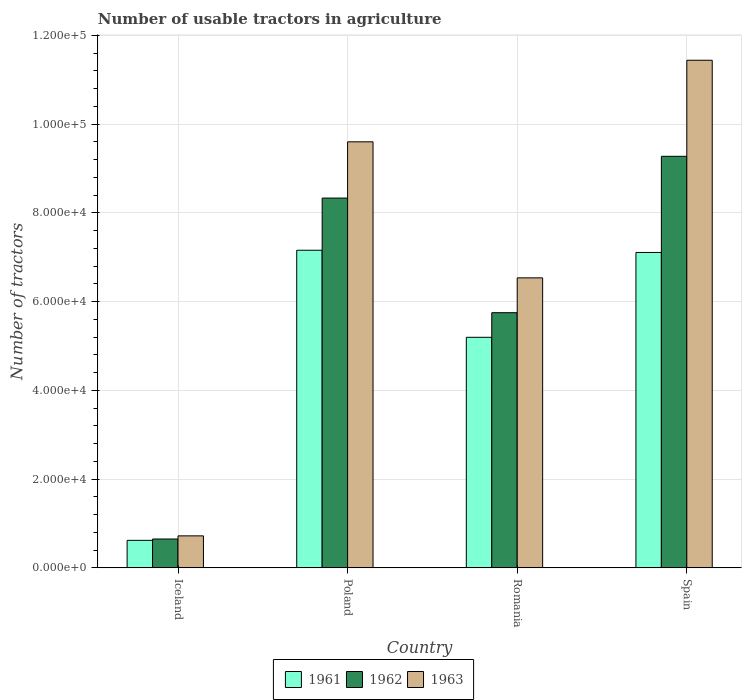Are the number of bars per tick equal to the number of legend labels?
Offer a very short reply. Yes. Are the number of bars on each tick of the X-axis equal?
Your answer should be very brief. Yes. How many bars are there on the 4th tick from the right?
Offer a terse response. 3. What is the number of usable tractors in agriculture in 1961 in Spain?
Keep it short and to the point. 7.11e+04. Across all countries, what is the maximum number of usable tractors in agriculture in 1961?
Offer a very short reply. 7.16e+04. Across all countries, what is the minimum number of usable tractors in agriculture in 1963?
Offer a very short reply. 7187. In which country was the number of usable tractors in agriculture in 1961 maximum?
Ensure brevity in your answer.  Poland. What is the total number of usable tractors in agriculture in 1962 in the graph?
Your answer should be very brief. 2.40e+05. What is the difference between the number of usable tractors in agriculture in 1962 in Poland and the number of usable tractors in agriculture in 1963 in Spain?
Your answer should be very brief. -3.11e+04. What is the average number of usable tractors in agriculture in 1963 per country?
Your answer should be compact. 7.07e+04. What is the difference between the number of usable tractors in agriculture of/in 1963 and number of usable tractors in agriculture of/in 1961 in Iceland?
Your answer should be compact. 1010. What is the ratio of the number of usable tractors in agriculture in 1961 in Romania to that in Spain?
Keep it short and to the point. 0.73. Is the difference between the number of usable tractors in agriculture in 1963 in Poland and Spain greater than the difference between the number of usable tractors in agriculture in 1961 in Poland and Spain?
Offer a terse response. No. What is the difference between the highest and the second highest number of usable tractors in agriculture in 1961?
Make the answer very short. -1.96e+04. What is the difference between the highest and the lowest number of usable tractors in agriculture in 1963?
Make the answer very short. 1.07e+05. Is the sum of the number of usable tractors in agriculture in 1961 in Iceland and Romania greater than the maximum number of usable tractors in agriculture in 1963 across all countries?
Offer a very short reply. No. What does the 3rd bar from the left in Iceland represents?
Offer a very short reply. 1963. What does the 3rd bar from the right in Iceland represents?
Ensure brevity in your answer.  1961. How many bars are there?
Keep it short and to the point. 12. How many countries are there in the graph?
Give a very brief answer. 4. What is the difference between two consecutive major ticks on the Y-axis?
Ensure brevity in your answer.  2.00e+04. Does the graph contain grids?
Give a very brief answer. Yes. Where does the legend appear in the graph?
Offer a terse response. Bottom center. What is the title of the graph?
Your answer should be very brief. Number of usable tractors in agriculture. Does "1987" appear as one of the legend labels in the graph?
Your response must be concise. No. What is the label or title of the Y-axis?
Your answer should be compact. Number of tractors. What is the Number of tractors of 1961 in Iceland?
Keep it short and to the point. 6177. What is the Number of tractors in 1962 in Iceland?
Provide a short and direct response. 6479. What is the Number of tractors of 1963 in Iceland?
Your response must be concise. 7187. What is the Number of tractors in 1961 in Poland?
Give a very brief answer. 7.16e+04. What is the Number of tractors in 1962 in Poland?
Provide a short and direct response. 8.33e+04. What is the Number of tractors in 1963 in Poland?
Your response must be concise. 9.60e+04. What is the Number of tractors of 1961 in Romania?
Provide a succinct answer. 5.20e+04. What is the Number of tractors in 1962 in Romania?
Offer a very short reply. 5.75e+04. What is the Number of tractors of 1963 in Romania?
Provide a short and direct response. 6.54e+04. What is the Number of tractors of 1961 in Spain?
Ensure brevity in your answer.  7.11e+04. What is the Number of tractors of 1962 in Spain?
Give a very brief answer. 9.28e+04. What is the Number of tractors in 1963 in Spain?
Ensure brevity in your answer.  1.14e+05. Across all countries, what is the maximum Number of tractors in 1961?
Give a very brief answer. 7.16e+04. Across all countries, what is the maximum Number of tractors in 1962?
Keep it short and to the point. 9.28e+04. Across all countries, what is the maximum Number of tractors in 1963?
Your answer should be compact. 1.14e+05. Across all countries, what is the minimum Number of tractors of 1961?
Make the answer very short. 6177. Across all countries, what is the minimum Number of tractors in 1962?
Your answer should be compact. 6479. Across all countries, what is the minimum Number of tractors of 1963?
Make the answer very short. 7187. What is the total Number of tractors of 1961 in the graph?
Offer a very short reply. 2.01e+05. What is the total Number of tractors of 1962 in the graph?
Provide a succinct answer. 2.40e+05. What is the total Number of tractors in 1963 in the graph?
Your answer should be compact. 2.83e+05. What is the difference between the Number of tractors in 1961 in Iceland and that in Poland?
Your answer should be very brief. -6.54e+04. What is the difference between the Number of tractors in 1962 in Iceland and that in Poland?
Your answer should be compact. -7.69e+04. What is the difference between the Number of tractors of 1963 in Iceland and that in Poland?
Your answer should be very brief. -8.88e+04. What is the difference between the Number of tractors in 1961 in Iceland and that in Romania?
Provide a short and direct response. -4.58e+04. What is the difference between the Number of tractors in 1962 in Iceland and that in Romania?
Your response must be concise. -5.10e+04. What is the difference between the Number of tractors in 1963 in Iceland and that in Romania?
Your answer should be very brief. -5.82e+04. What is the difference between the Number of tractors of 1961 in Iceland and that in Spain?
Your answer should be very brief. -6.49e+04. What is the difference between the Number of tractors of 1962 in Iceland and that in Spain?
Keep it short and to the point. -8.63e+04. What is the difference between the Number of tractors in 1963 in Iceland and that in Spain?
Your answer should be very brief. -1.07e+05. What is the difference between the Number of tractors in 1961 in Poland and that in Romania?
Provide a short and direct response. 1.96e+04. What is the difference between the Number of tractors of 1962 in Poland and that in Romania?
Ensure brevity in your answer.  2.58e+04. What is the difference between the Number of tractors of 1963 in Poland and that in Romania?
Provide a succinct answer. 3.07e+04. What is the difference between the Number of tractors of 1962 in Poland and that in Spain?
Keep it short and to the point. -9414. What is the difference between the Number of tractors in 1963 in Poland and that in Spain?
Your response must be concise. -1.84e+04. What is the difference between the Number of tractors in 1961 in Romania and that in Spain?
Give a very brief answer. -1.91e+04. What is the difference between the Number of tractors in 1962 in Romania and that in Spain?
Keep it short and to the point. -3.53e+04. What is the difference between the Number of tractors in 1963 in Romania and that in Spain?
Ensure brevity in your answer.  -4.91e+04. What is the difference between the Number of tractors in 1961 in Iceland and the Number of tractors in 1962 in Poland?
Provide a short and direct response. -7.72e+04. What is the difference between the Number of tractors in 1961 in Iceland and the Number of tractors in 1963 in Poland?
Your answer should be very brief. -8.98e+04. What is the difference between the Number of tractors of 1962 in Iceland and the Number of tractors of 1963 in Poland?
Provide a short and direct response. -8.95e+04. What is the difference between the Number of tractors in 1961 in Iceland and the Number of tractors in 1962 in Romania?
Your answer should be very brief. -5.13e+04. What is the difference between the Number of tractors of 1961 in Iceland and the Number of tractors of 1963 in Romania?
Offer a terse response. -5.92e+04. What is the difference between the Number of tractors in 1962 in Iceland and the Number of tractors in 1963 in Romania?
Provide a succinct answer. -5.89e+04. What is the difference between the Number of tractors in 1961 in Iceland and the Number of tractors in 1962 in Spain?
Your response must be concise. -8.66e+04. What is the difference between the Number of tractors of 1961 in Iceland and the Number of tractors of 1963 in Spain?
Offer a terse response. -1.08e+05. What is the difference between the Number of tractors of 1962 in Iceland and the Number of tractors of 1963 in Spain?
Your answer should be compact. -1.08e+05. What is the difference between the Number of tractors in 1961 in Poland and the Number of tractors in 1962 in Romania?
Offer a very short reply. 1.41e+04. What is the difference between the Number of tractors in 1961 in Poland and the Number of tractors in 1963 in Romania?
Your response must be concise. 6226. What is the difference between the Number of tractors of 1962 in Poland and the Number of tractors of 1963 in Romania?
Make the answer very short. 1.80e+04. What is the difference between the Number of tractors in 1961 in Poland and the Number of tractors in 1962 in Spain?
Give a very brief answer. -2.12e+04. What is the difference between the Number of tractors of 1961 in Poland and the Number of tractors of 1963 in Spain?
Provide a succinct answer. -4.28e+04. What is the difference between the Number of tractors in 1962 in Poland and the Number of tractors in 1963 in Spain?
Your answer should be very brief. -3.11e+04. What is the difference between the Number of tractors of 1961 in Romania and the Number of tractors of 1962 in Spain?
Offer a very short reply. -4.08e+04. What is the difference between the Number of tractors of 1961 in Romania and the Number of tractors of 1963 in Spain?
Your response must be concise. -6.25e+04. What is the difference between the Number of tractors of 1962 in Romania and the Number of tractors of 1963 in Spain?
Give a very brief answer. -5.69e+04. What is the average Number of tractors in 1961 per country?
Your response must be concise. 5.02e+04. What is the average Number of tractors in 1962 per country?
Provide a succinct answer. 6.00e+04. What is the average Number of tractors in 1963 per country?
Provide a short and direct response. 7.07e+04. What is the difference between the Number of tractors in 1961 and Number of tractors in 1962 in Iceland?
Your response must be concise. -302. What is the difference between the Number of tractors in 1961 and Number of tractors in 1963 in Iceland?
Offer a very short reply. -1010. What is the difference between the Number of tractors of 1962 and Number of tractors of 1963 in Iceland?
Your response must be concise. -708. What is the difference between the Number of tractors in 1961 and Number of tractors in 1962 in Poland?
Your answer should be very brief. -1.18e+04. What is the difference between the Number of tractors of 1961 and Number of tractors of 1963 in Poland?
Offer a very short reply. -2.44e+04. What is the difference between the Number of tractors in 1962 and Number of tractors in 1963 in Poland?
Give a very brief answer. -1.27e+04. What is the difference between the Number of tractors in 1961 and Number of tractors in 1962 in Romania?
Your response must be concise. -5548. What is the difference between the Number of tractors of 1961 and Number of tractors of 1963 in Romania?
Provide a short and direct response. -1.34e+04. What is the difference between the Number of tractors in 1962 and Number of tractors in 1963 in Romania?
Ensure brevity in your answer.  -7851. What is the difference between the Number of tractors of 1961 and Number of tractors of 1962 in Spain?
Your answer should be compact. -2.17e+04. What is the difference between the Number of tractors in 1961 and Number of tractors in 1963 in Spain?
Give a very brief answer. -4.33e+04. What is the difference between the Number of tractors of 1962 and Number of tractors of 1963 in Spain?
Your response must be concise. -2.17e+04. What is the ratio of the Number of tractors of 1961 in Iceland to that in Poland?
Provide a short and direct response. 0.09. What is the ratio of the Number of tractors in 1962 in Iceland to that in Poland?
Give a very brief answer. 0.08. What is the ratio of the Number of tractors in 1963 in Iceland to that in Poland?
Ensure brevity in your answer.  0.07. What is the ratio of the Number of tractors of 1961 in Iceland to that in Romania?
Keep it short and to the point. 0.12. What is the ratio of the Number of tractors of 1962 in Iceland to that in Romania?
Provide a short and direct response. 0.11. What is the ratio of the Number of tractors of 1963 in Iceland to that in Romania?
Provide a short and direct response. 0.11. What is the ratio of the Number of tractors in 1961 in Iceland to that in Spain?
Provide a succinct answer. 0.09. What is the ratio of the Number of tractors in 1962 in Iceland to that in Spain?
Your answer should be compact. 0.07. What is the ratio of the Number of tractors in 1963 in Iceland to that in Spain?
Make the answer very short. 0.06. What is the ratio of the Number of tractors of 1961 in Poland to that in Romania?
Offer a terse response. 1.38. What is the ratio of the Number of tractors of 1962 in Poland to that in Romania?
Keep it short and to the point. 1.45. What is the ratio of the Number of tractors in 1963 in Poland to that in Romania?
Ensure brevity in your answer.  1.47. What is the ratio of the Number of tractors in 1961 in Poland to that in Spain?
Your response must be concise. 1.01. What is the ratio of the Number of tractors in 1962 in Poland to that in Spain?
Give a very brief answer. 0.9. What is the ratio of the Number of tractors in 1963 in Poland to that in Spain?
Make the answer very short. 0.84. What is the ratio of the Number of tractors in 1961 in Romania to that in Spain?
Your answer should be very brief. 0.73. What is the ratio of the Number of tractors of 1962 in Romania to that in Spain?
Offer a terse response. 0.62. What is the ratio of the Number of tractors in 1963 in Romania to that in Spain?
Offer a very short reply. 0.57. What is the difference between the highest and the second highest Number of tractors of 1962?
Your response must be concise. 9414. What is the difference between the highest and the second highest Number of tractors in 1963?
Offer a very short reply. 1.84e+04. What is the difference between the highest and the lowest Number of tractors of 1961?
Provide a succinct answer. 6.54e+04. What is the difference between the highest and the lowest Number of tractors of 1962?
Your answer should be compact. 8.63e+04. What is the difference between the highest and the lowest Number of tractors in 1963?
Make the answer very short. 1.07e+05. 